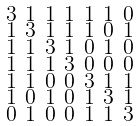Convert formula to latex. <formula><loc_0><loc_0><loc_500><loc_500>\begin{smallmatrix} 3 & 1 & 1 & 1 & 1 & 1 & 0 \\ 1 & 3 & 1 & 1 & 1 & 0 & 1 \\ 1 & 1 & 3 & 1 & 0 & 1 & 0 \\ 1 & 1 & 1 & 3 & 0 & 0 & 0 \\ 1 & 1 & 0 & 0 & 3 & 1 & 1 \\ 1 & 0 & 1 & 0 & 1 & 3 & 1 \\ 0 & 1 & 0 & 0 & 1 & 1 & 3 \end{smallmatrix}</formula> 